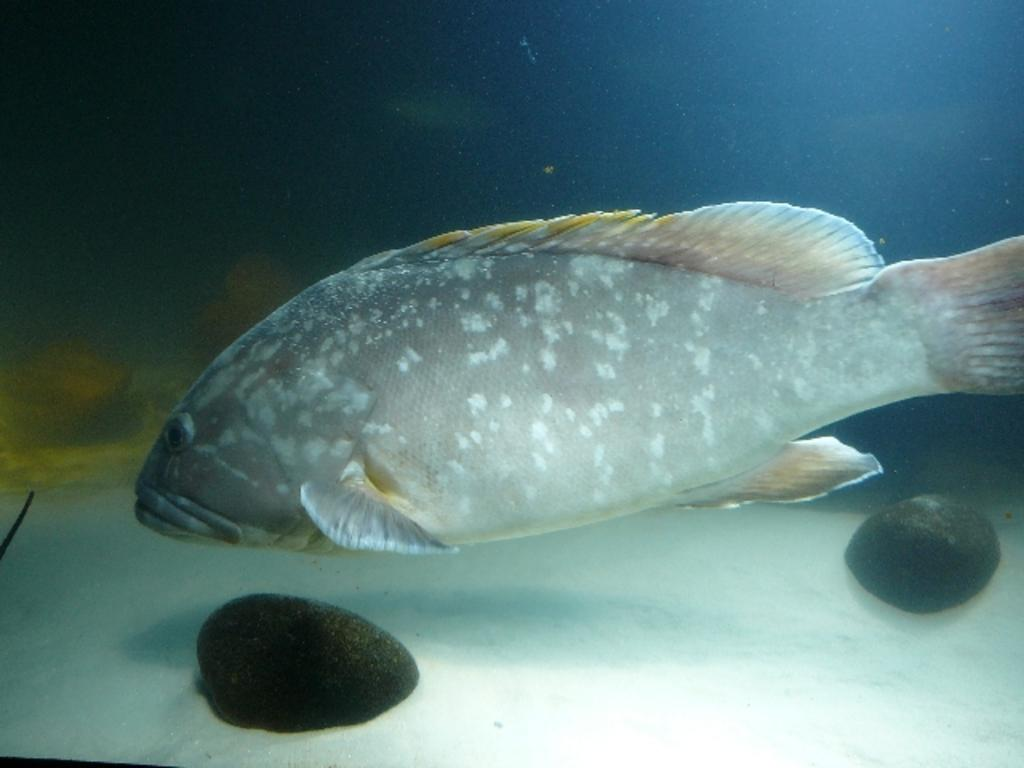What type of animals can be seen in the image? Fish can be seen in the water in the image. What other objects or elements are present in the image? There are stones in the image. What time of day is it in the image, and how does the holiday affect the fish? There is no indication of time of day or any holiday in the image, and the fish are not affected by any holiday. 